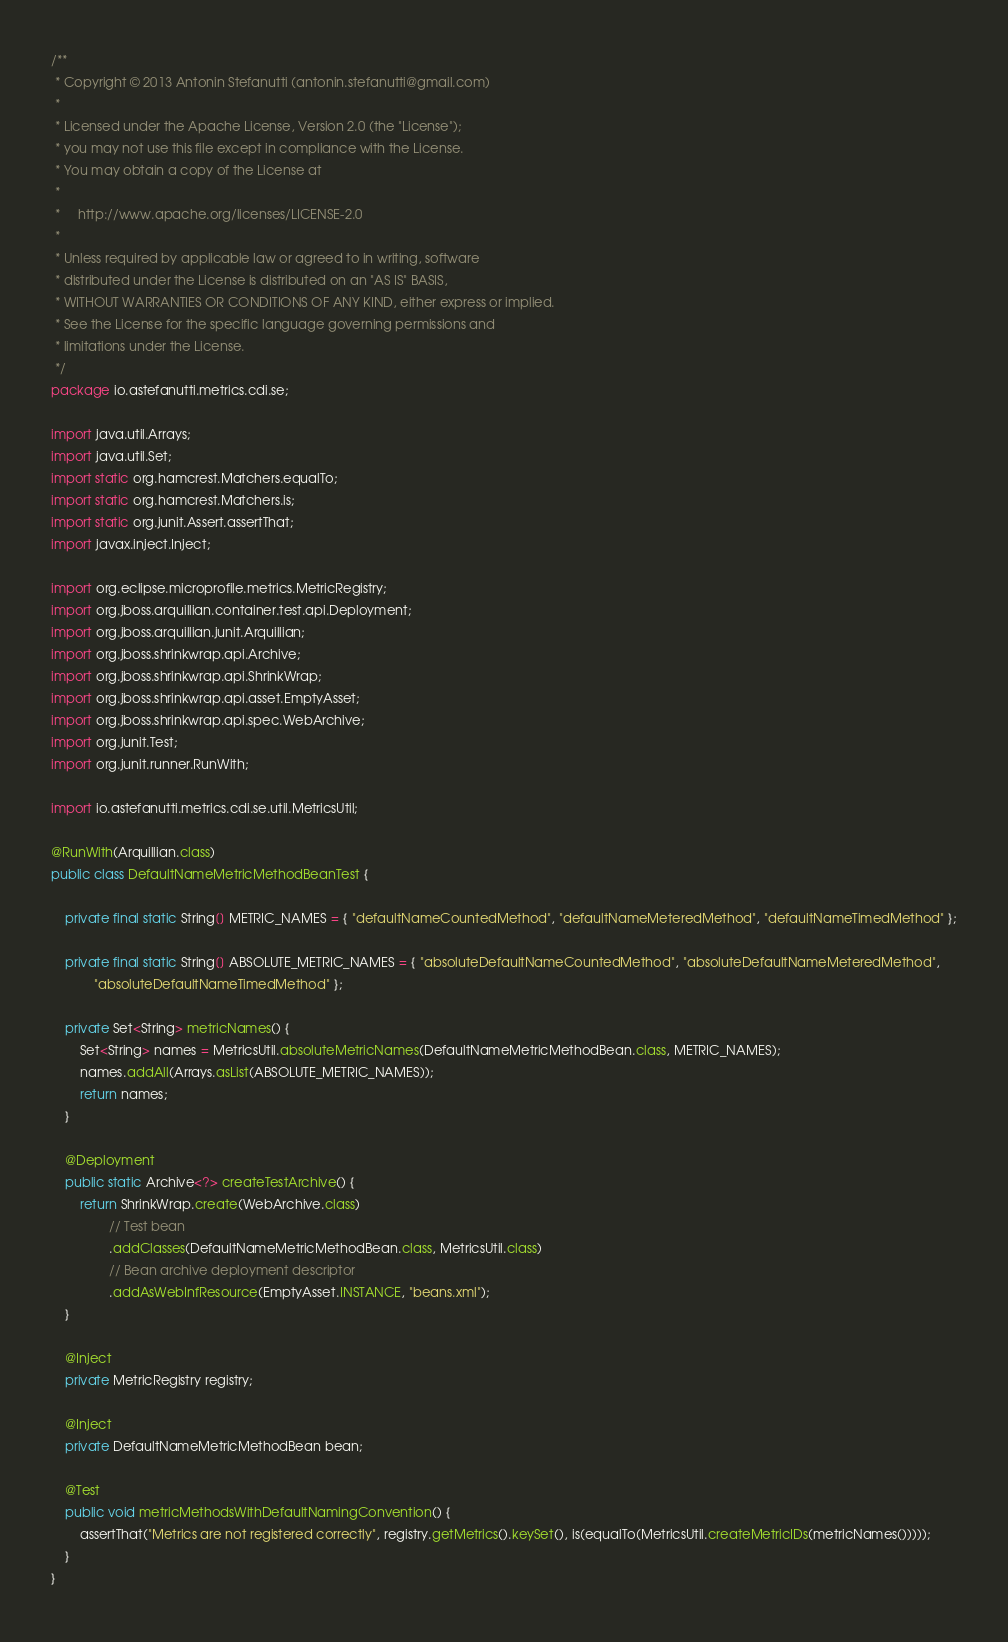Convert code to text. <code><loc_0><loc_0><loc_500><loc_500><_Java_>/**
 * Copyright © 2013 Antonin Stefanutti (antonin.stefanutti@gmail.com)
 *
 * Licensed under the Apache License, Version 2.0 (the "License");
 * you may not use this file except in compliance with the License.
 * You may obtain a copy of the License at
 *
 *     http://www.apache.org/licenses/LICENSE-2.0
 *
 * Unless required by applicable law or agreed to in writing, software
 * distributed under the License is distributed on an "AS IS" BASIS,
 * WITHOUT WARRANTIES OR CONDITIONS OF ANY KIND, either express or implied.
 * See the License for the specific language governing permissions and
 * limitations under the License.
 */
package io.astefanutti.metrics.cdi.se;

import java.util.Arrays;
import java.util.Set;
import static org.hamcrest.Matchers.equalTo;
import static org.hamcrest.Matchers.is;
import static org.junit.Assert.assertThat;
import javax.inject.Inject;

import org.eclipse.microprofile.metrics.MetricRegistry;
import org.jboss.arquillian.container.test.api.Deployment;
import org.jboss.arquillian.junit.Arquillian;
import org.jboss.shrinkwrap.api.Archive;
import org.jboss.shrinkwrap.api.ShrinkWrap;
import org.jboss.shrinkwrap.api.asset.EmptyAsset;
import org.jboss.shrinkwrap.api.spec.WebArchive;
import org.junit.Test;
import org.junit.runner.RunWith;

import io.astefanutti.metrics.cdi.se.util.MetricsUtil;

@RunWith(Arquillian.class)
public class DefaultNameMetricMethodBeanTest {

    private final static String[] METRIC_NAMES = { "defaultNameCountedMethod", "defaultNameMeteredMethod", "defaultNameTimedMethod" };

    private final static String[] ABSOLUTE_METRIC_NAMES = { "absoluteDefaultNameCountedMethod", "absoluteDefaultNameMeteredMethod",
            "absoluteDefaultNameTimedMethod" };

    private Set<String> metricNames() {
        Set<String> names = MetricsUtil.absoluteMetricNames(DefaultNameMetricMethodBean.class, METRIC_NAMES);
        names.addAll(Arrays.asList(ABSOLUTE_METRIC_NAMES));
        return names;
    }

    @Deployment
    public static Archive<?> createTestArchive() {
        return ShrinkWrap.create(WebArchive.class)
                // Test bean
                .addClasses(DefaultNameMetricMethodBean.class, MetricsUtil.class)
                // Bean archive deployment descriptor
                .addAsWebInfResource(EmptyAsset.INSTANCE, "beans.xml");
    }

    @Inject
    private MetricRegistry registry;

    @Inject
    private DefaultNameMetricMethodBean bean;

    @Test
    public void metricMethodsWithDefaultNamingConvention() {
        assertThat("Metrics are not registered correctly", registry.getMetrics().keySet(), is(equalTo(MetricsUtil.createMetricIDs(metricNames()))));
    }
}</code> 